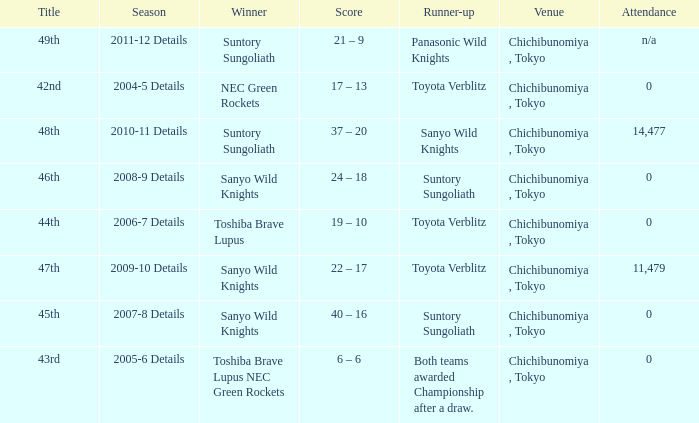What is the Score when the winner was sanyo wild knights, and a Runner-up of suntory sungoliath? 40 – 16, 24 – 18. 